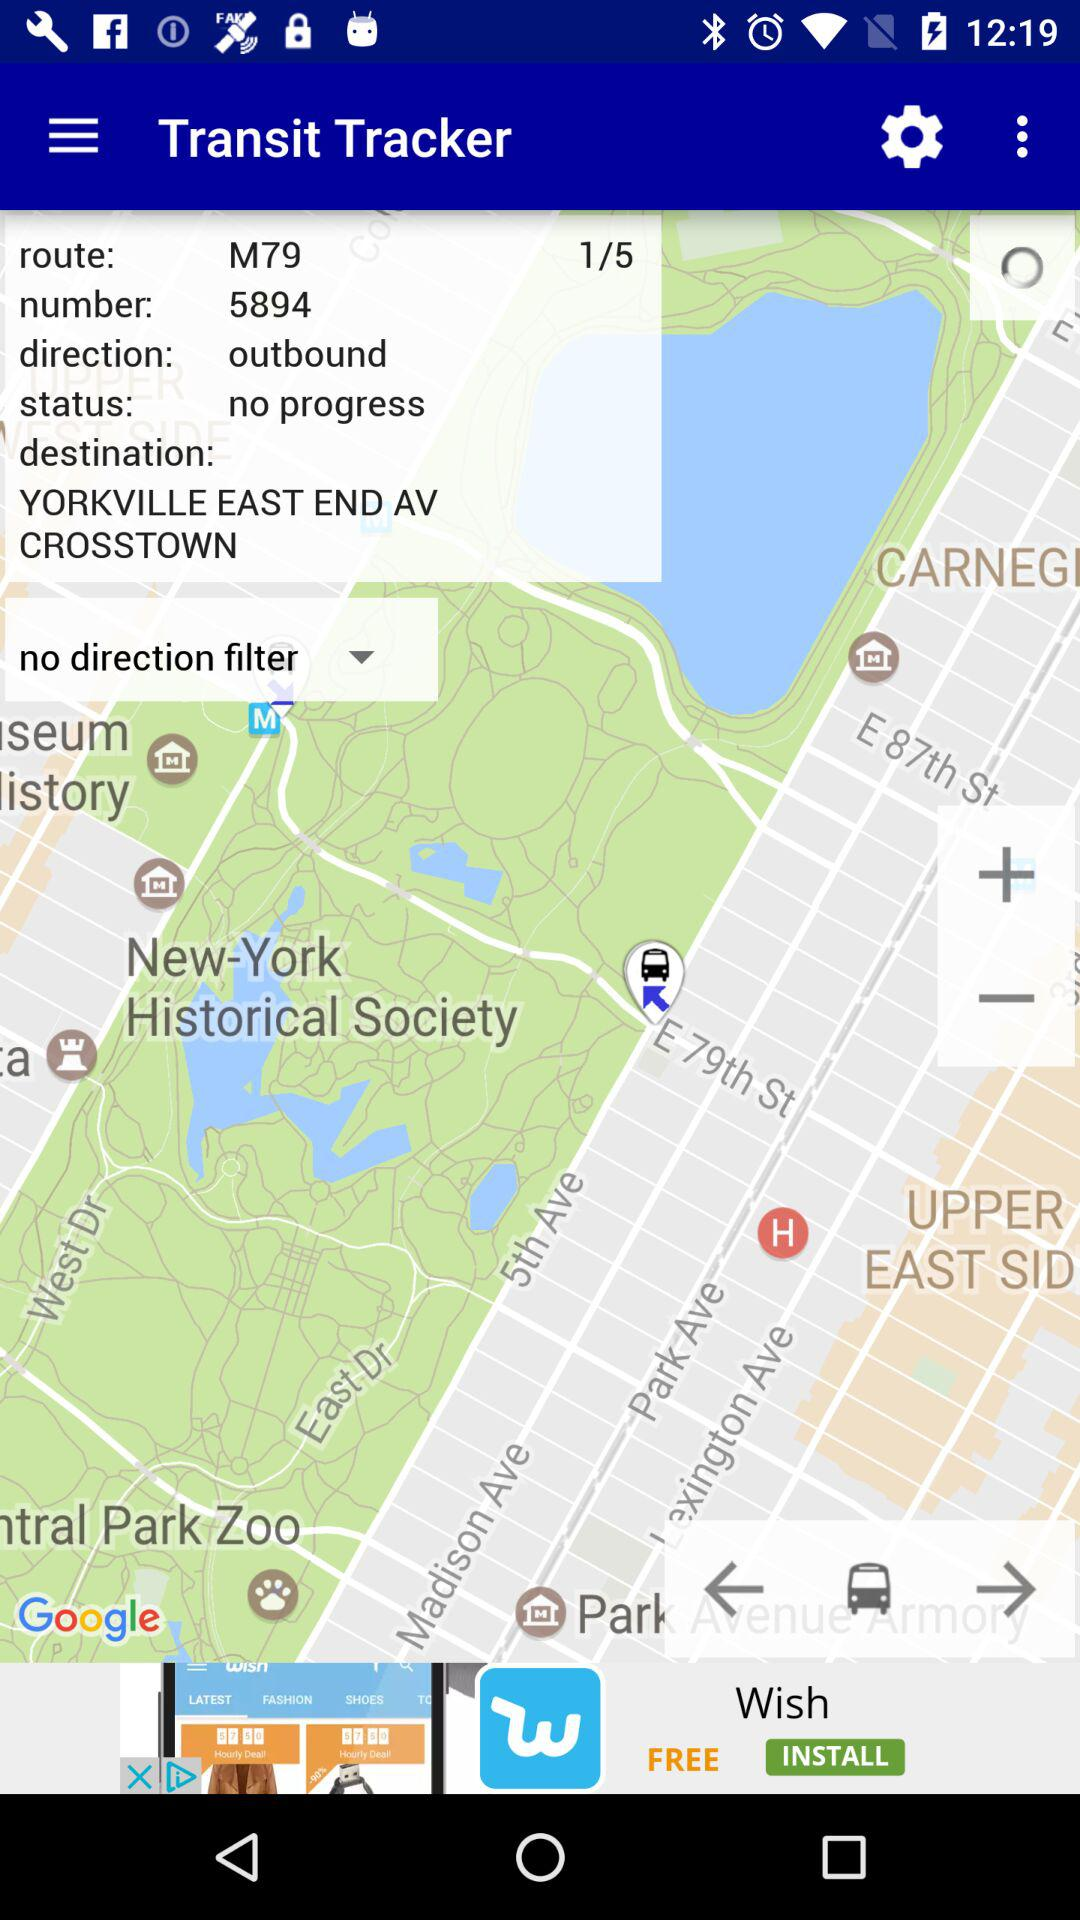What is the route number? The route number is M79. 